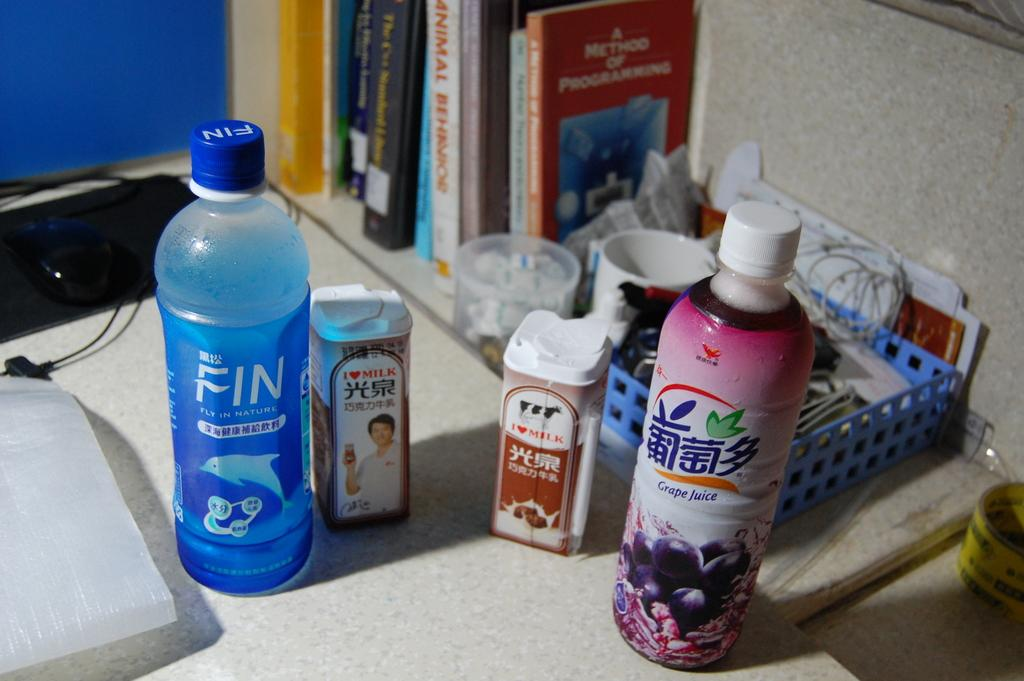<image>
Provide a brief description of the given image. A bottle of Fin says Fly in Nature. 